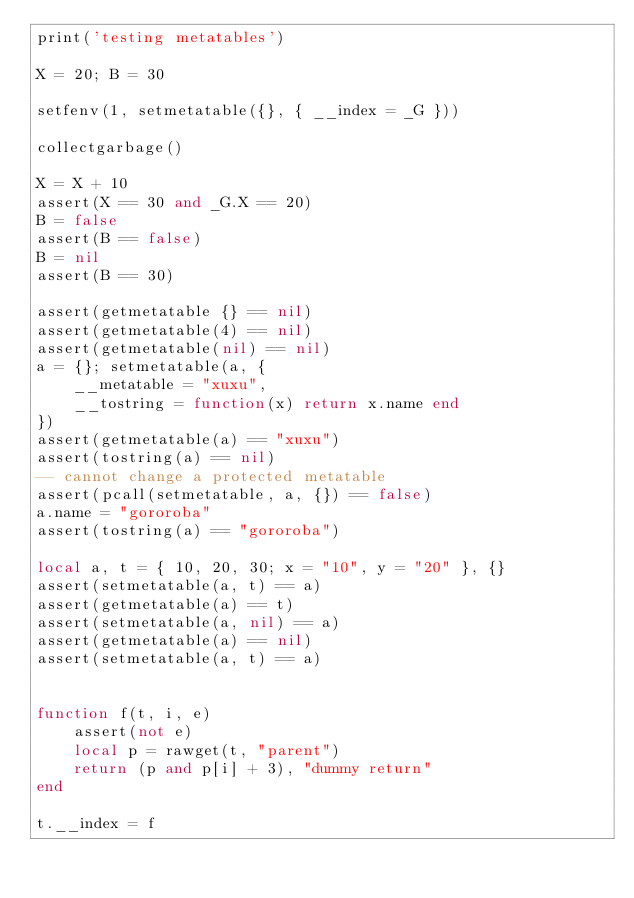<code> <loc_0><loc_0><loc_500><loc_500><_Lua_>print('testing metatables')

X = 20; B = 30

setfenv(1, setmetatable({}, { __index = _G }))

collectgarbage()

X = X + 10
assert(X == 30 and _G.X == 20)
B = false
assert(B == false)
B = nil
assert(B == 30)

assert(getmetatable {} == nil)
assert(getmetatable(4) == nil)
assert(getmetatable(nil) == nil)
a = {}; setmetatable(a, {
	__metatable = "xuxu",
	__tostring = function(x) return x.name end
})
assert(getmetatable(a) == "xuxu")
assert(tostring(a) == nil)
-- cannot change a protected metatable
assert(pcall(setmetatable, a, {}) == false)
a.name = "gororoba"
assert(tostring(a) == "gororoba")

local a, t = { 10, 20, 30; x = "10", y = "20" }, {}
assert(setmetatable(a, t) == a)
assert(getmetatable(a) == t)
assert(setmetatable(a, nil) == a)
assert(getmetatable(a) == nil)
assert(setmetatable(a, t) == a)


function f(t, i, e)
	assert(not e)
	local p = rawget(t, "parent")
	return (p and p[i] + 3), "dummy return"
end

t.__index = f
</code> 